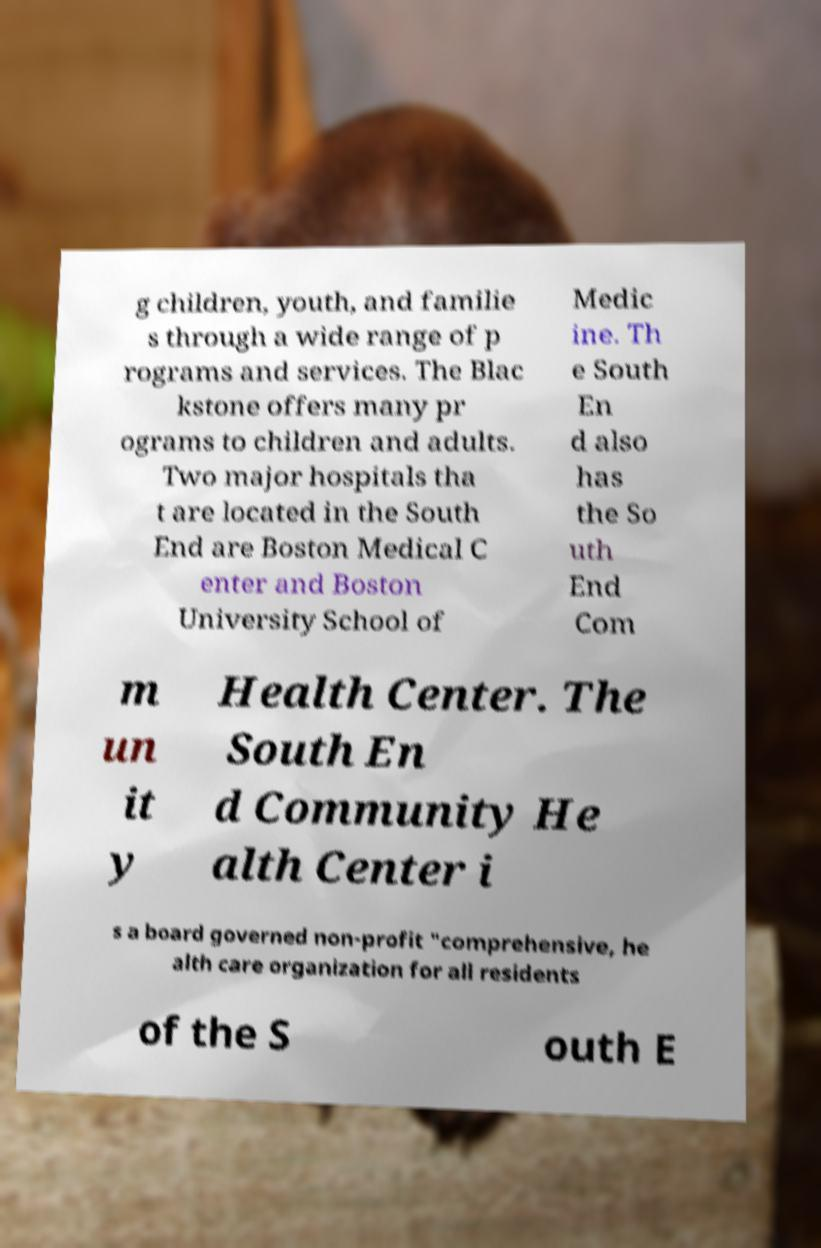Can you read and provide the text displayed in the image?This photo seems to have some interesting text. Can you extract and type it out for me? g children, youth, and familie s through a wide range of p rograms and services. The Blac kstone offers many pr ograms to children and adults. Two major hospitals tha t are located in the South End are Boston Medical C enter and Boston University School of Medic ine. Th e South En d also has the So uth End Com m un it y Health Center. The South En d Community He alth Center i s a board governed non-profit "comprehensive, he alth care organization for all residents of the S outh E 